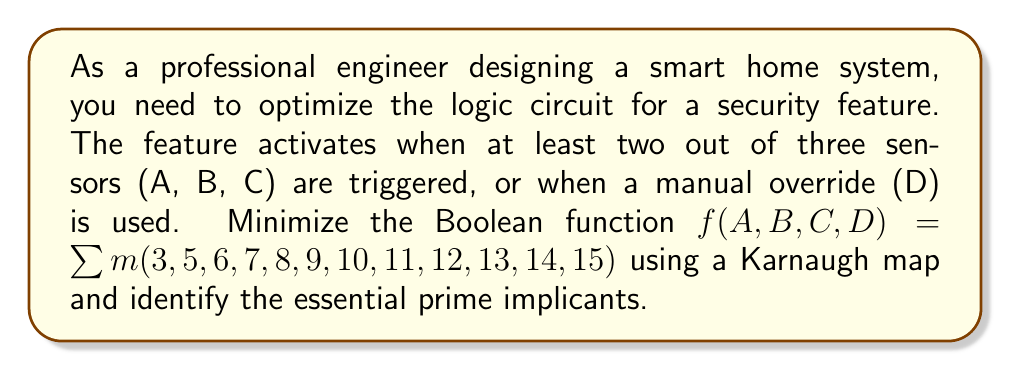Help me with this question. 1. First, let's create a 4-variable Karnaugh map:

[asy]
unitsize(1cm);
int i,j;
for(i=0; i<4; ++i) {
  for(j=0; j<4; ++j) {
    draw((i,j)--(i+1,j)--(i+1,j+1)--(i,j+1)--cycle);
  }
}
label("00", (0.5,-0.5));
label("01", (1.5,-0.5));
label("11", (2.5,-0.5));
label("10", (3.5,-0.5));
label("00", (-0.5,0.5));
label("01", (-0.5,1.5));
label("11", (-0.5,2.5));
label("10", (-0.5,3.5));
label("AB", (-0.5,-0.5));
label("CD", (4.5,1.5));
label("0", (0.5,0.5));
label("0", (1.5,0.5));
label("1", (2.5,0.5));
label("1", (3.5,0.5));
label("0", (0.5,1.5));
label("1", (1.5,1.5));
label("1", (2.5,1.5));
label("1", (3.5,1.5));
label("1", (0.5,2.5));
label("1", (1.5,2.5));
label("1", (2.5,2.5));
label("1", (3.5,2.5));
label("1", (0.5,3.5));
label("1", (1.5,3.5));
label("1", (2.5,3.5));
label("1", (3.5,3.5));
[/asy]

2. Identify the prime implicants:
   - $CD$ (covers 8 cells)
   - $AB$ (covers 4 cells)
   - $AC$ (covers 4 cells)
   - $BC$ (covers 4 cells)

3. Determine essential prime implicants:
   - $CD$ is essential as it's the only one covering minterms 8, 9, 10, 11
   - $AB$ is essential as it's the only one covering minterm 3
   - Either $AC$ or $BC$ is needed to cover minterm 5 or 6, respectively

4. The minimized function can be expressed as:
   $f(A,B,C,D) = CD + AB + AC$
   or
   $f(A,B,C,D) = CD + AB + BC$

5. Essential prime implicants:
   - $CD$ (representing the manual override)
   - $AB$ (representing two of the three sensors being triggered)
Answer: $f(A,B,C,D) = CD + AB + AC$; Essential prime implicants: $CD$, $AB$ 